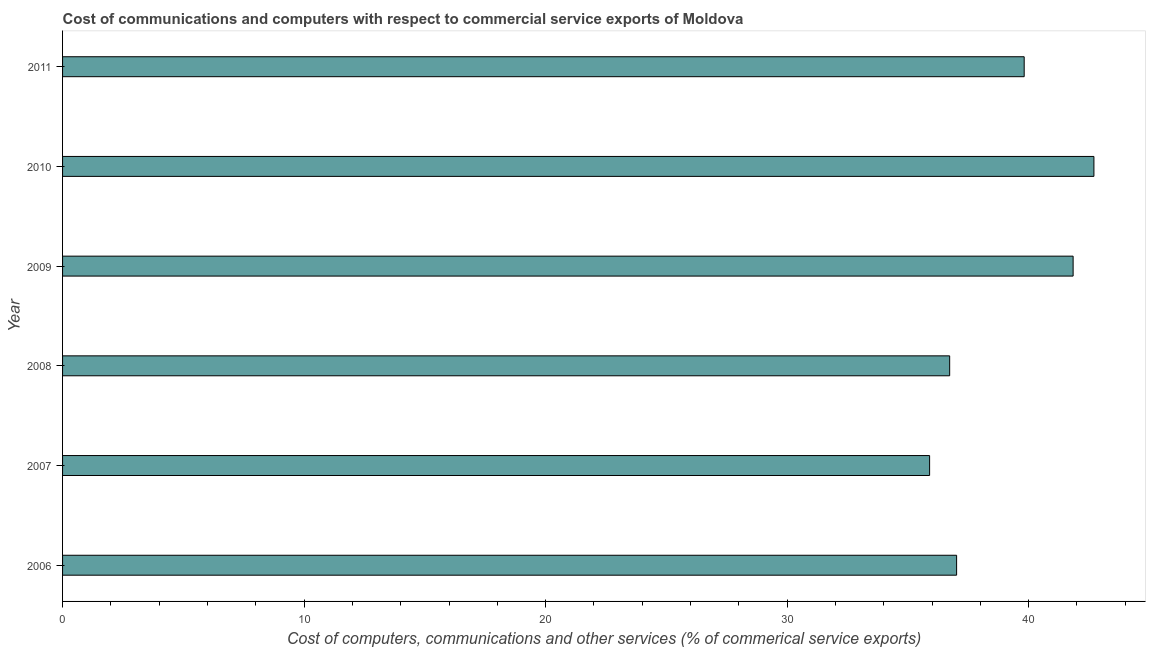Does the graph contain any zero values?
Offer a very short reply. No. Does the graph contain grids?
Offer a very short reply. No. What is the title of the graph?
Offer a very short reply. Cost of communications and computers with respect to commercial service exports of Moldova. What is the label or title of the X-axis?
Your answer should be very brief. Cost of computers, communications and other services (% of commerical service exports). What is the cost of communications in 2010?
Make the answer very short. 42.7. Across all years, what is the maximum cost of communications?
Your answer should be very brief. 42.7. Across all years, what is the minimum  computer and other services?
Provide a succinct answer. 35.9. In which year was the  computer and other services maximum?
Offer a terse response. 2010. What is the sum of the  computer and other services?
Your answer should be compact. 234.01. What is the difference between the  computer and other services in 2006 and 2010?
Provide a succinct answer. -5.69. What is the average  computer and other services per year?
Offer a very short reply. 39. What is the median  computer and other services?
Your answer should be compact. 38.42. In how many years, is the  computer and other services greater than 22 %?
Provide a succinct answer. 6. What is the ratio of the cost of communications in 2008 to that in 2010?
Ensure brevity in your answer.  0.86. Is the difference between the  computer and other services in 2007 and 2011 greater than the difference between any two years?
Provide a short and direct response. No. What is the difference between the highest and the second highest cost of communications?
Provide a succinct answer. 0.86. Is the sum of the  computer and other services in 2006 and 2009 greater than the maximum  computer and other services across all years?
Offer a terse response. Yes. In how many years, is the  computer and other services greater than the average  computer and other services taken over all years?
Offer a terse response. 3. How many bars are there?
Your answer should be very brief. 6. How many years are there in the graph?
Your answer should be very brief. 6. Are the values on the major ticks of X-axis written in scientific E-notation?
Your answer should be very brief. No. What is the Cost of computers, communications and other services (% of commerical service exports) in 2006?
Ensure brevity in your answer.  37.02. What is the Cost of computers, communications and other services (% of commerical service exports) of 2007?
Your answer should be compact. 35.9. What is the Cost of computers, communications and other services (% of commerical service exports) in 2008?
Give a very brief answer. 36.73. What is the Cost of computers, communications and other services (% of commerical service exports) of 2009?
Ensure brevity in your answer.  41.84. What is the Cost of computers, communications and other services (% of commerical service exports) of 2010?
Ensure brevity in your answer.  42.7. What is the Cost of computers, communications and other services (% of commerical service exports) of 2011?
Make the answer very short. 39.82. What is the difference between the Cost of computers, communications and other services (% of commerical service exports) in 2006 and 2007?
Keep it short and to the point. 1.12. What is the difference between the Cost of computers, communications and other services (% of commerical service exports) in 2006 and 2008?
Provide a short and direct response. 0.29. What is the difference between the Cost of computers, communications and other services (% of commerical service exports) in 2006 and 2009?
Your response must be concise. -4.82. What is the difference between the Cost of computers, communications and other services (% of commerical service exports) in 2006 and 2010?
Keep it short and to the point. -5.69. What is the difference between the Cost of computers, communications and other services (% of commerical service exports) in 2006 and 2011?
Ensure brevity in your answer.  -2.8. What is the difference between the Cost of computers, communications and other services (% of commerical service exports) in 2007 and 2008?
Make the answer very short. -0.83. What is the difference between the Cost of computers, communications and other services (% of commerical service exports) in 2007 and 2009?
Your answer should be compact. -5.94. What is the difference between the Cost of computers, communications and other services (% of commerical service exports) in 2007 and 2010?
Give a very brief answer. -6.8. What is the difference between the Cost of computers, communications and other services (% of commerical service exports) in 2007 and 2011?
Ensure brevity in your answer.  -3.92. What is the difference between the Cost of computers, communications and other services (% of commerical service exports) in 2008 and 2009?
Provide a succinct answer. -5.11. What is the difference between the Cost of computers, communications and other services (% of commerical service exports) in 2008 and 2010?
Provide a short and direct response. -5.97. What is the difference between the Cost of computers, communications and other services (% of commerical service exports) in 2008 and 2011?
Your answer should be compact. -3.09. What is the difference between the Cost of computers, communications and other services (% of commerical service exports) in 2009 and 2010?
Offer a terse response. -0.86. What is the difference between the Cost of computers, communications and other services (% of commerical service exports) in 2009 and 2011?
Offer a very short reply. 2.03. What is the difference between the Cost of computers, communications and other services (% of commerical service exports) in 2010 and 2011?
Your answer should be very brief. 2.89. What is the ratio of the Cost of computers, communications and other services (% of commerical service exports) in 2006 to that in 2007?
Offer a very short reply. 1.03. What is the ratio of the Cost of computers, communications and other services (% of commerical service exports) in 2006 to that in 2009?
Offer a very short reply. 0.89. What is the ratio of the Cost of computers, communications and other services (% of commerical service exports) in 2006 to that in 2010?
Give a very brief answer. 0.87. What is the ratio of the Cost of computers, communications and other services (% of commerical service exports) in 2006 to that in 2011?
Provide a succinct answer. 0.93. What is the ratio of the Cost of computers, communications and other services (% of commerical service exports) in 2007 to that in 2008?
Make the answer very short. 0.98. What is the ratio of the Cost of computers, communications and other services (% of commerical service exports) in 2007 to that in 2009?
Give a very brief answer. 0.86. What is the ratio of the Cost of computers, communications and other services (% of commerical service exports) in 2007 to that in 2010?
Give a very brief answer. 0.84. What is the ratio of the Cost of computers, communications and other services (% of commerical service exports) in 2007 to that in 2011?
Offer a very short reply. 0.9. What is the ratio of the Cost of computers, communications and other services (% of commerical service exports) in 2008 to that in 2009?
Keep it short and to the point. 0.88. What is the ratio of the Cost of computers, communications and other services (% of commerical service exports) in 2008 to that in 2010?
Offer a terse response. 0.86. What is the ratio of the Cost of computers, communications and other services (% of commerical service exports) in 2008 to that in 2011?
Make the answer very short. 0.92. What is the ratio of the Cost of computers, communications and other services (% of commerical service exports) in 2009 to that in 2011?
Your answer should be compact. 1.05. What is the ratio of the Cost of computers, communications and other services (% of commerical service exports) in 2010 to that in 2011?
Your answer should be very brief. 1.07. 